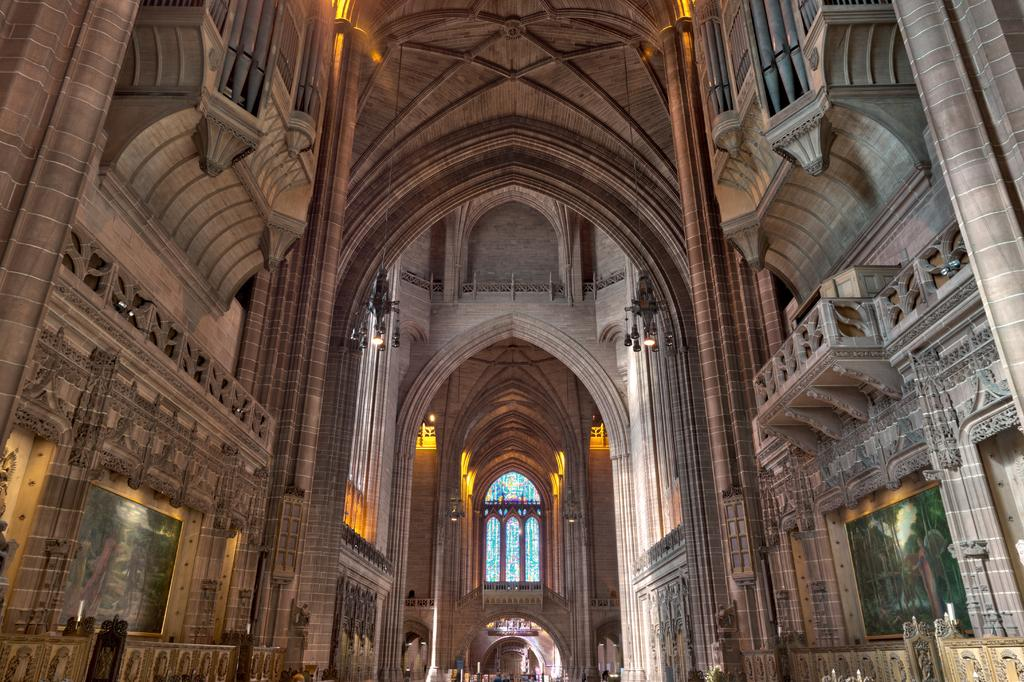What type of structure is present in the image? There is a building in the image. Can you describe any specific features of the building? The building has a window. What rule is being enforced by the smoke coming out of the window in the image? There is no smoke coming out of the window in the image, and therefore no rule being enforced. What type of sky is visible in the image? The provided facts do not mention the sky, so it cannot be determined from the image. 